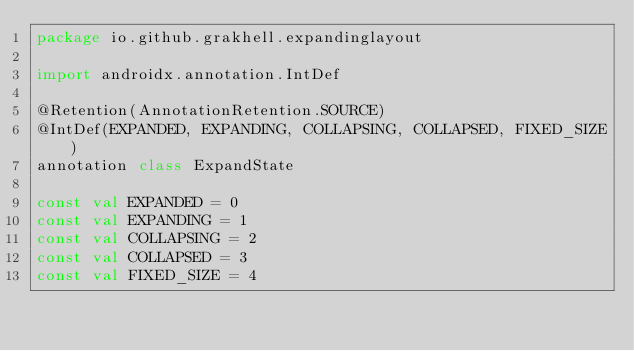<code> <loc_0><loc_0><loc_500><loc_500><_Kotlin_>package io.github.grakhell.expandinglayout

import androidx.annotation.IntDef

@Retention(AnnotationRetention.SOURCE)
@IntDef(EXPANDED, EXPANDING, COLLAPSING, COLLAPSED, FIXED_SIZE)
annotation class ExpandState

const val EXPANDED = 0
const val EXPANDING = 1
const val COLLAPSING = 2
const val COLLAPSED = 3
const val FIXED_SIZE = 4</code> 